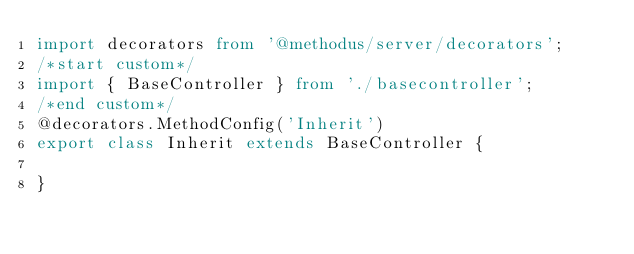Convert code to text. <code><loc_0><loc_0><loc_500><loc_500><_TypeScript_>import decorators from '@methodus/server/decorators';
/*start custom*/
import { BaseController } from './basecontroller';
/*end custom*/
@decorators.MethodConfig('Inherit')
export class Inherit extends BaseController {

}
</code> 